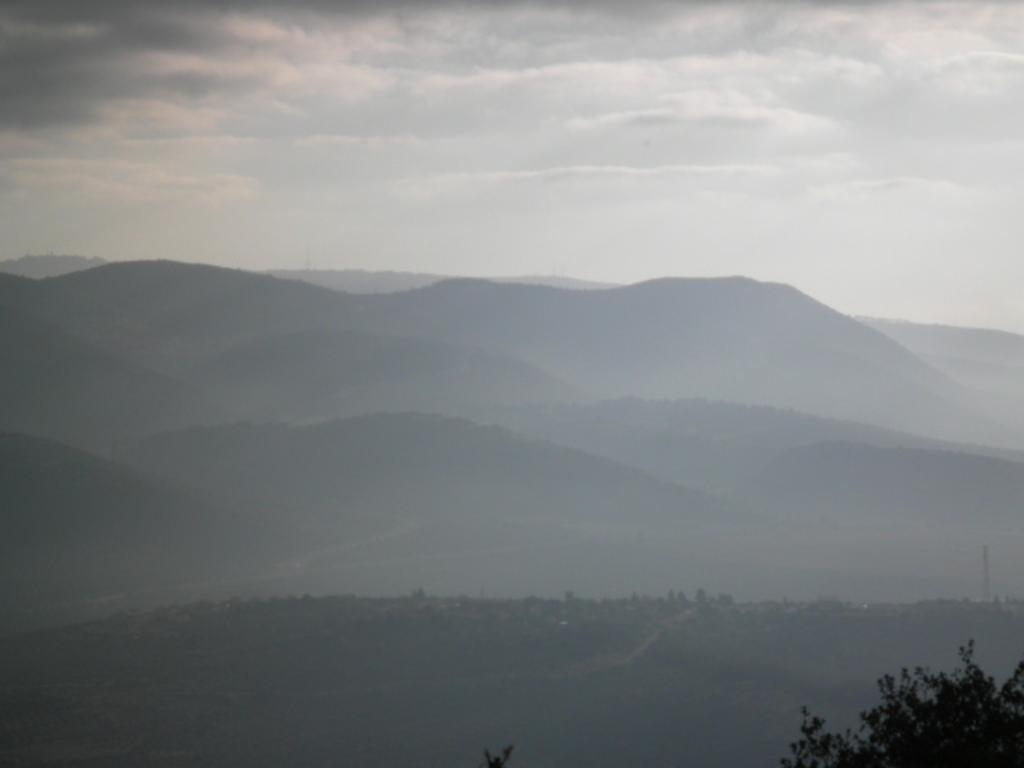What type of landscape is depicted in the image? The image contains hills. What other natural elements can be seen in the image? The image contains trees. How would you describe the weather in the image? The sky is cloudy in the image. What type of writing can be seen on the trees in the image? There is no writing visible on the trees in the image. What type of body of water is present in the image? There is no body of water present in the image; it only contains hills and trees. 